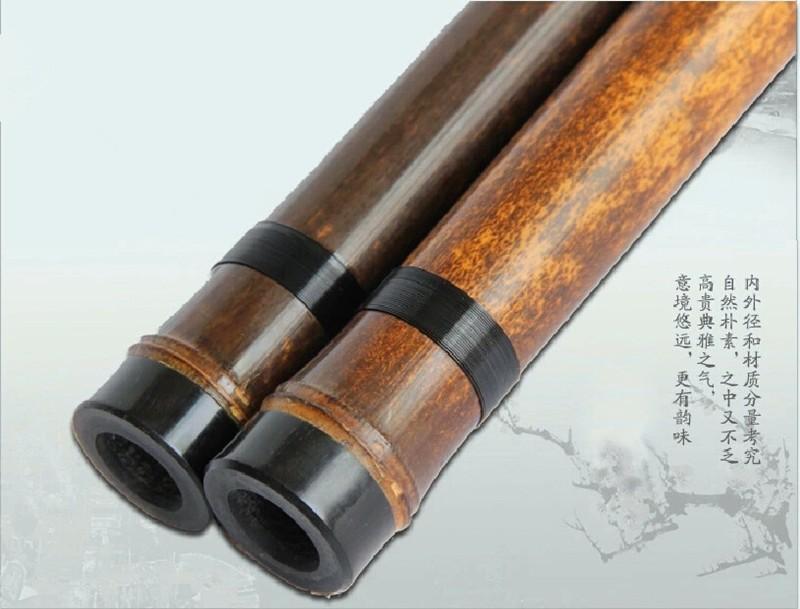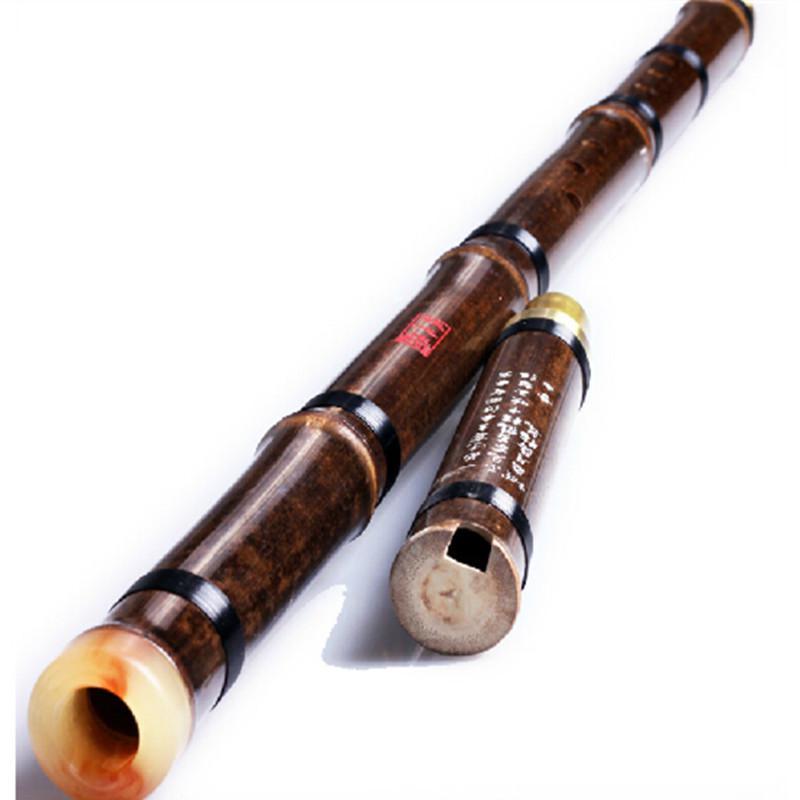The first image is the image on the left, the second image is the image on the right. Assess this claim about the two images: "In the left image, we've got two flute parts parallel to each other.". Correct or not? Answer yes or no. Yes. The first image is the image on the left, the second image is the image on the right. For the images displayed, is the sentence "There is a single flute bar with the left side at the bottom, there are no other pieces in the image." factually correct? Answer yes or no. No. 